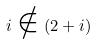Convert formula to latex. <formula><loc_0><loc_0><loc_500><loc_500>i \notin ( 2 + i )</formula> 